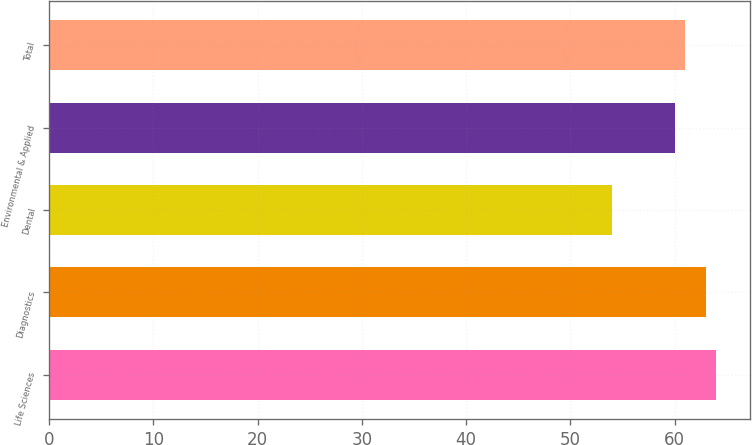<chart> <loc_0><loc_0><loc_500><loc_500><bar_chart><fcel>Life Sciences<fcel>Diagnostics<fcel>Dental<fcel>Environmental & Applied<fcel>Total<nl><fcel>64<fcel>63<fcel>54<fcel>60<fcel>61<nl></chart> 